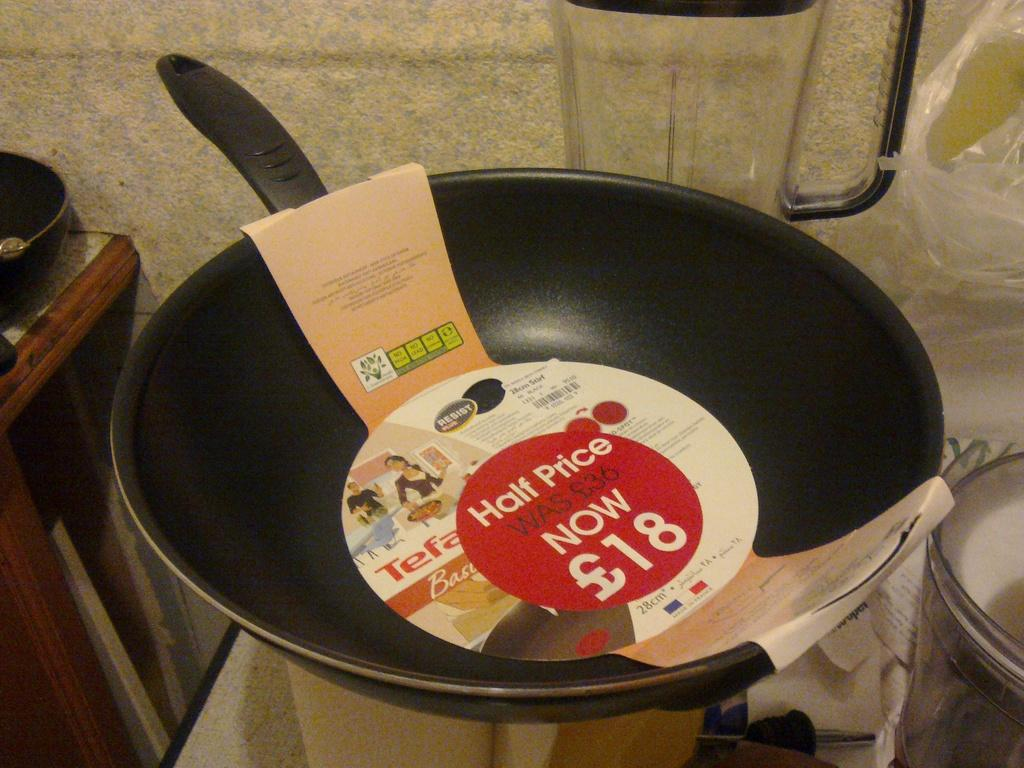<image>
Render a clear and concise summary of the photo. A new frying pan has a half price sticker on it. 